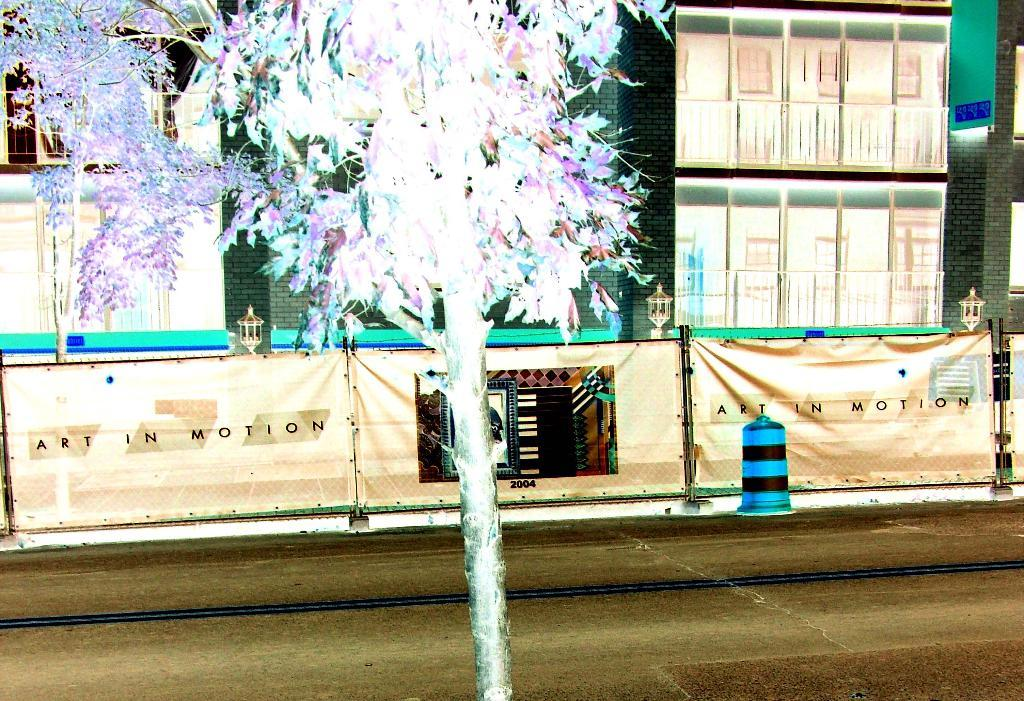What type of structure is depicted in the edited picture in the image? The image contains an edited picture of a building. What features can be observed on the building? The building has windows and lights. What additional element is present in the image? There is a banner with text in the image. What can be seen in the foreground of the image? There is a tree and a cone placed on the ground in the foreground of the image. Can you see any waves or a coastline in the image? No, there are no waves or coastline visible in the image; it features a building with a banner and a tree in the foreground. What type of machine is being used to fly the kite in the image? There is no kite present in the image, so it is not possible to determine what type of machine might be used to fly one. 